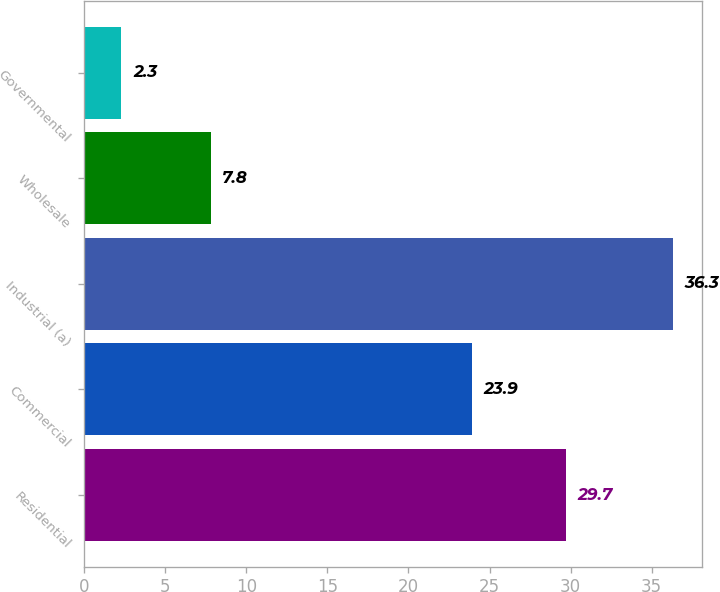<chart> <loc_0><loc_0><loc_500><loc_500><bar_chart><fcel>Residential<fcel>Commercial<fcel>Industrial (a)<fcel>Wholesale<fcel>Governmental<nl><fcel>29.7<fcel>23.9<fcel>36.3<fcel>7.8<fcel>2.3<nl></chart> 